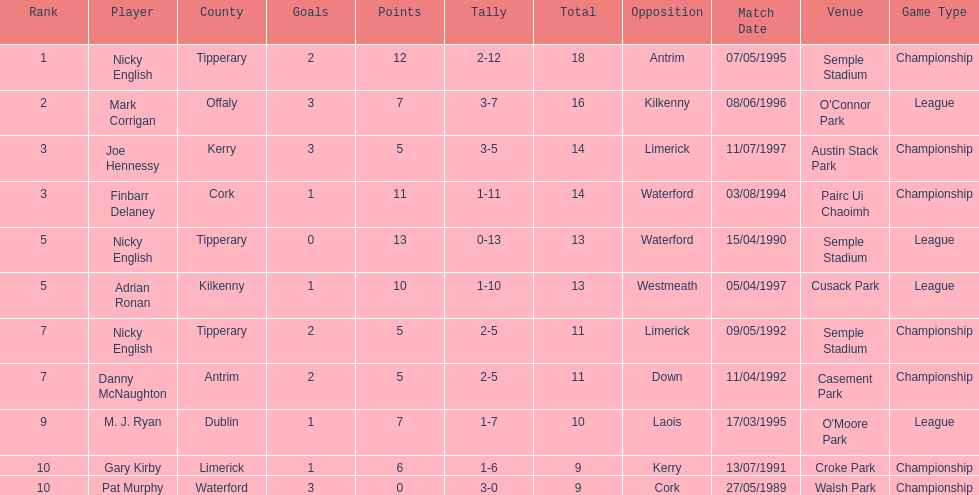If you added all the total's up, what would the number be? 138. 